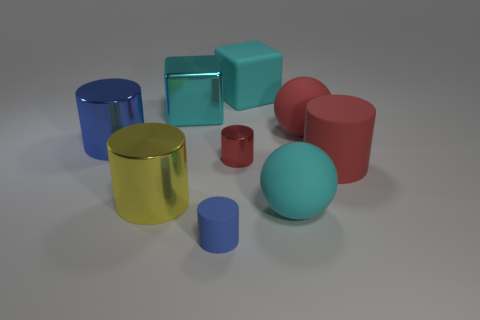Subtract all yellow cylinders. How many cylinders are left? 4 Subtract 2 cylinders. How many cylinders are left? 3 Subtract all yellow metallic cylinders. How many cylinders are left? 4 Subtract all purple cylinders. Subtract all purple blocks. How many cylinders are left? 5 Add 1 big red things. How many objects exist? 10 Subtract all cylinders. How many objects are left? 4 Subtract all red metallic objects. Subtract all big shiny cylinders. How many objects are left? 6 Add 1 cyan shiny cubes. How many cyan shiny cubes are left? 2 Add 4 purple matte objects. How many purple matte objects exist? 4 Subtract 0 green spheres. How many objects are left? 9 